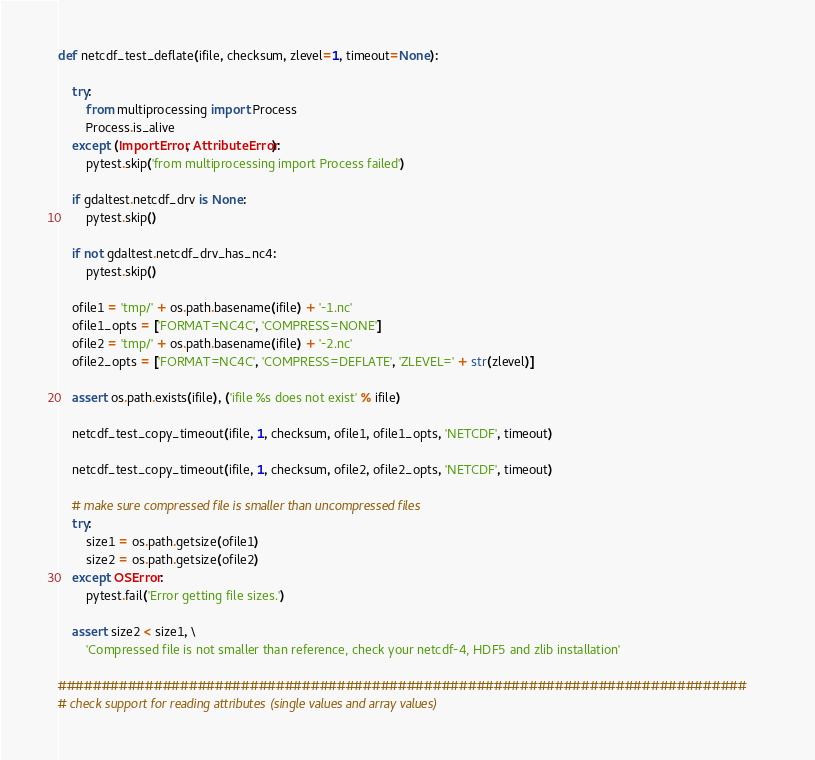Convert code to text. <code><loc_0><loc_0><loc_500><loc_500><_Python_>

def netcdf_test_deflate(ifile, checksum, zlevel=1, timeout=None):

    try:
        from multiprocessing import Process
        Process.is_alive
    except (ImportError, AttributeError):
        pytest.skip('from multiprocessing import Process failed')

    if gdaltest.netcdf_drv is None:
        pytest.skip()

    if not gdaltest.netcdf_drv_has_nc4:
        pytest.skip()

    ofile1 = 'tmp/' + os.path.basename(ifile) + '-1.nc'
    ofile1_opts = ['FORMAT=NC4C', 'COMPRESS=NONE']
    ofile2 = 'tmp/' + os.path.basename(ifile) + '-2.nc'
    ofile2_opts = ['FORMAT=NC4C', 'COMPRESS=DEFLATE', 'ZLEVEL=' + str(zlevel)]

    assert os.path.exists(ifile), ('ifile %s does not exist' % ifile)

    netcdf_test_copy_timeout(ifile, 1, checksum, ofile1, ofile1_opts, 'NETCDF', timeout)

    netcdf_test_copy_timeout(ifile, 1, checksum, ofile2, ofile2_opts, 'NETCDF', timeout)

    # make sure compressed file is smaller than uncompressed files
    try:
        size1 = os.path.getsize(ofile1)
        size2 = os.path.getsize(ofile2)
    except OSError:
        pytest.fail('Error getting file sizes.')

    assert size2 < size1, \
        'Compressed file is not smaller than reference, check your netcdf-4, HDF5 and zlib installation'

###############################################################################
# check support for reading attributes (single values and array values)

</code> 